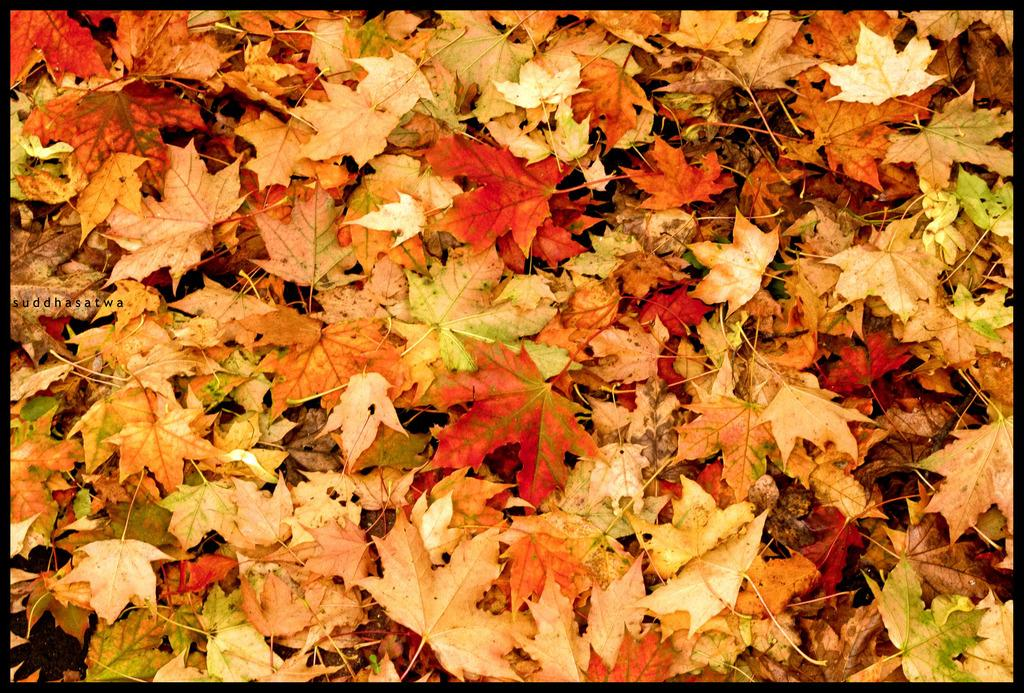What type of natural elements can be seen in the image? There are leaves in the image. What color are the leaves? The leaves are in orange color. How many servants are present in the image? There are no servants present in the image; it only features orange leaves. What type of boats can be seen in the image? There are no boats present in the image; it only features orange leaves. 